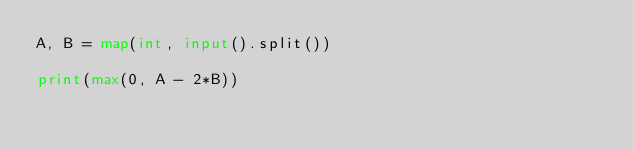<code> <loc_0><loc_0><loc_500><loc_500><_Python_>A, B = map(int, input().split())

print(max(0, A - 2*B))
</code> 